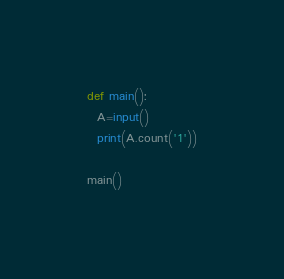Convert code to text. <code><loc_0><loc_0><loc_500><loc_500><_Python_>def main():
  A=input()
  print(A.count('1'))

main()</code> 